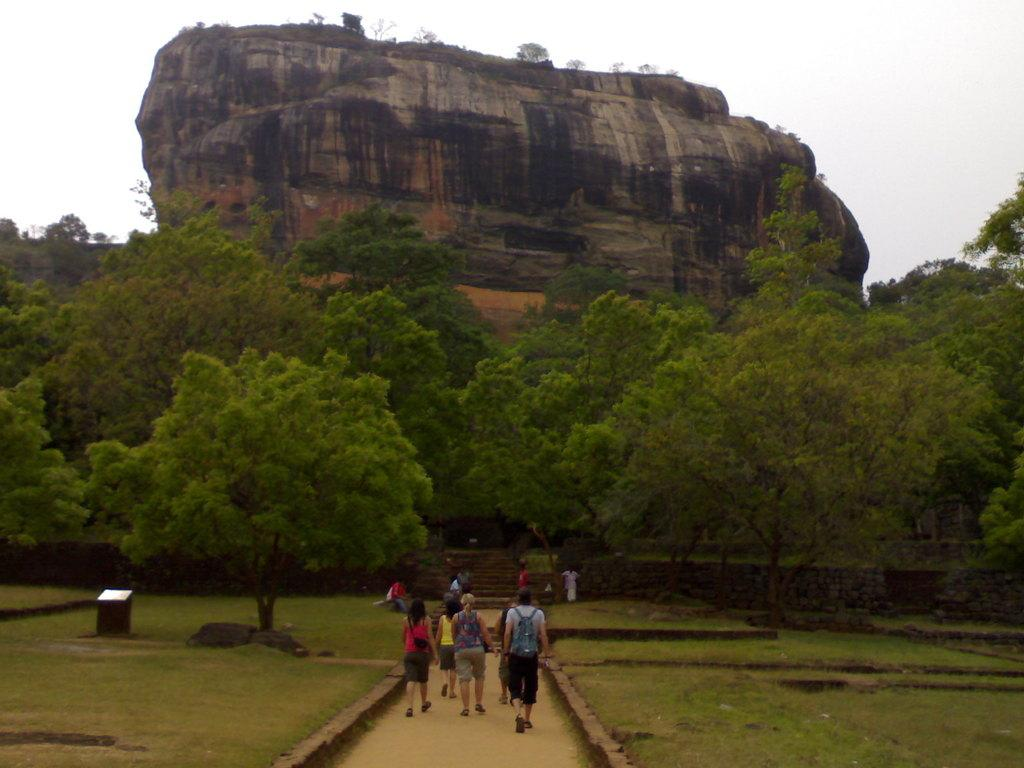What are the people in the image doing? The people in the image are walking. What are the people wearing on their feet? The people are wearing shoes. What are some people carrying in the image? Some people are carrying bags. What type of surface can be seen beneath the people's feet? There is a path visible in the image. What type of vegetation is present in the image? There is grass and trees in the image. What is the largest object visible in the image? The largest object visible in the image is a rock. What is visible above the people in the image? The sky is visible in the image. What is the price of the fan in the image? There is no fan present in the image, so it is not possible to determine its price. 